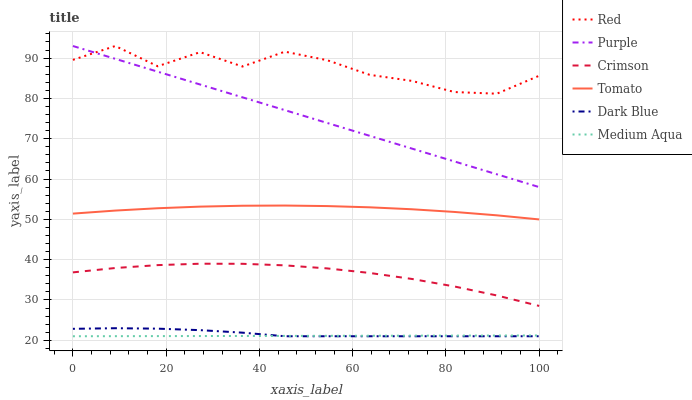Does Medium Aqua have the minimum area under the curve?
Answer yes or no. Yes. Does Red have the maximum area under the curve?
Answer yes or no. Yes. Does Purple have the minimum area under the curve?
Answer yes or no. No. Does Purple have the maximum area under the curve?
Answer yes or no. No. Is Medium Aqua the smoothest?
Answer yes or no. Yes. Is Red the roughest?
Answer yes or no. Yes. Is Purple the smoothest?
Answer yes or no. No. Is Purple the roughest?
Answer yes or no. No. Does Dark Blue have the lowest value?
Answer yes or no. Yes. Does Purple have the lowest value?
Answer yes or no. No. Does Red have the highest value?
Answer yes or no. Yes. Does Dark Blue have the highest value?
Answer yes or no. No. Is Medium Aqua less than Purple?
Answer yes or no. Yes. Is Red greater than Crimson?
Answer yes or no. Yes. Does Dark Blue intersect Medium Aqua?
Answer yes or no. Yes. Is Dark Blue less than Medium Aqua?
Answer yes or no. No. Is Dark Blue greater than Medium Aqua?
Answer yes or no. No. Does Medium Aqua intersect Purple?
Answer yes or no. No. 